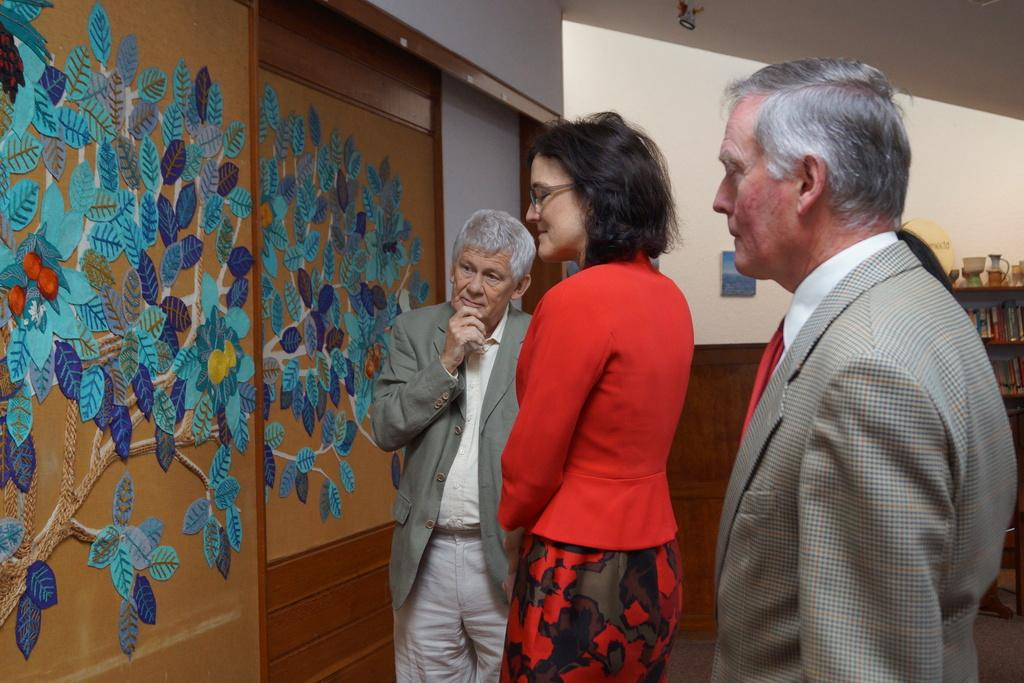How many people are in the image? There are people in the image, but the exact number is not specified. What is the background of the image? The people are standing in front of a wall. What is on the wall? There is a painting on the wall. What are the people doing in the image? The people are looking at the painting. What type of vessel is being used by the people in the image? There is no vessel present in the image. How many feet are visible in the image? The number of feet visible in the image is not specified, and it is not relevant to the main subject of the image. 